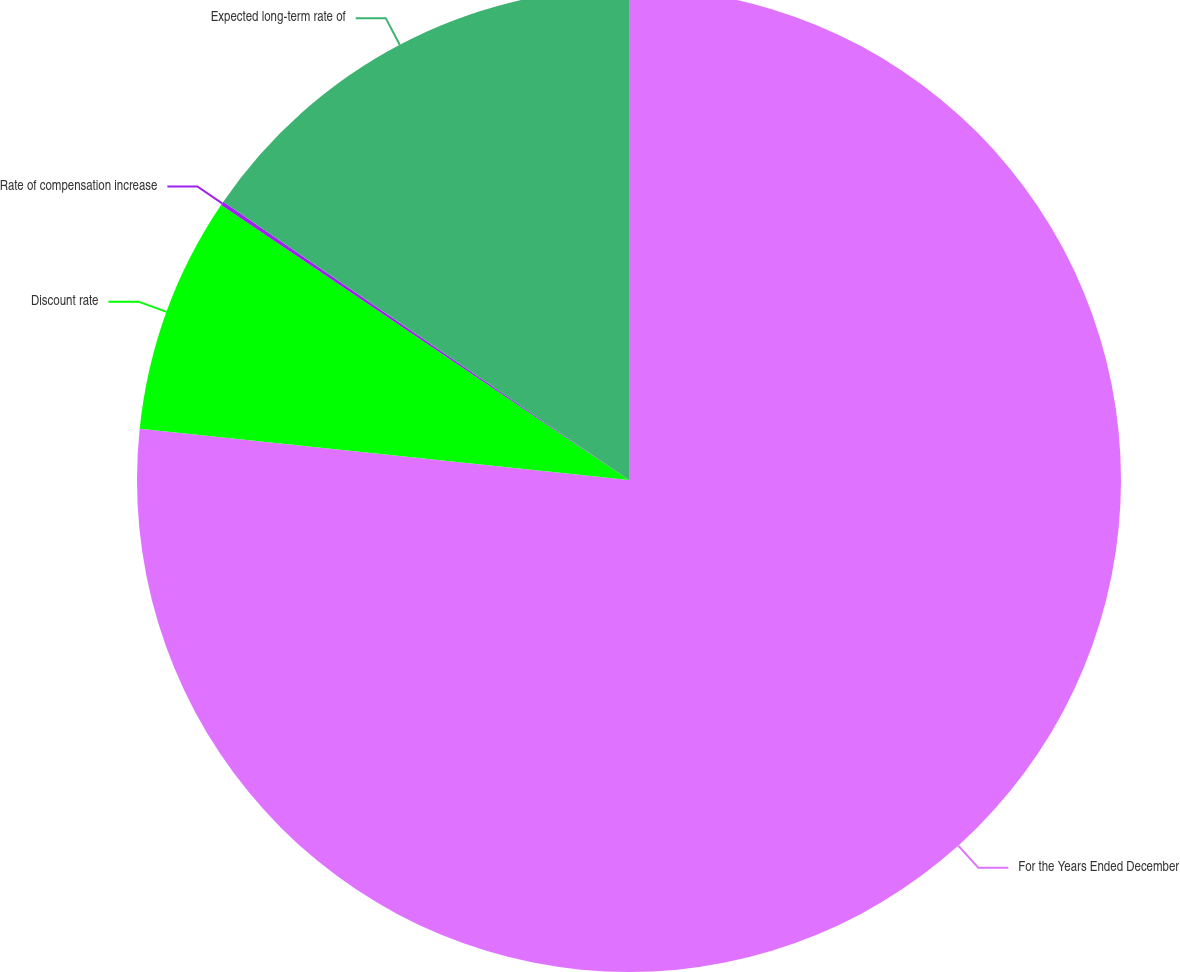Convert chart to OTSL. <chart><loc_0><loc_0><loc_500><loc_500><pie_chart><fcel>For the Years Ended December<fcel>Discount rate<fcel>Rate of compensation increase<fcel>Expected long-term rate of<nl><fcel>76.66%<fcel>7.78%<fcel>0.13%<fcel>15.43%<nl></chart> 